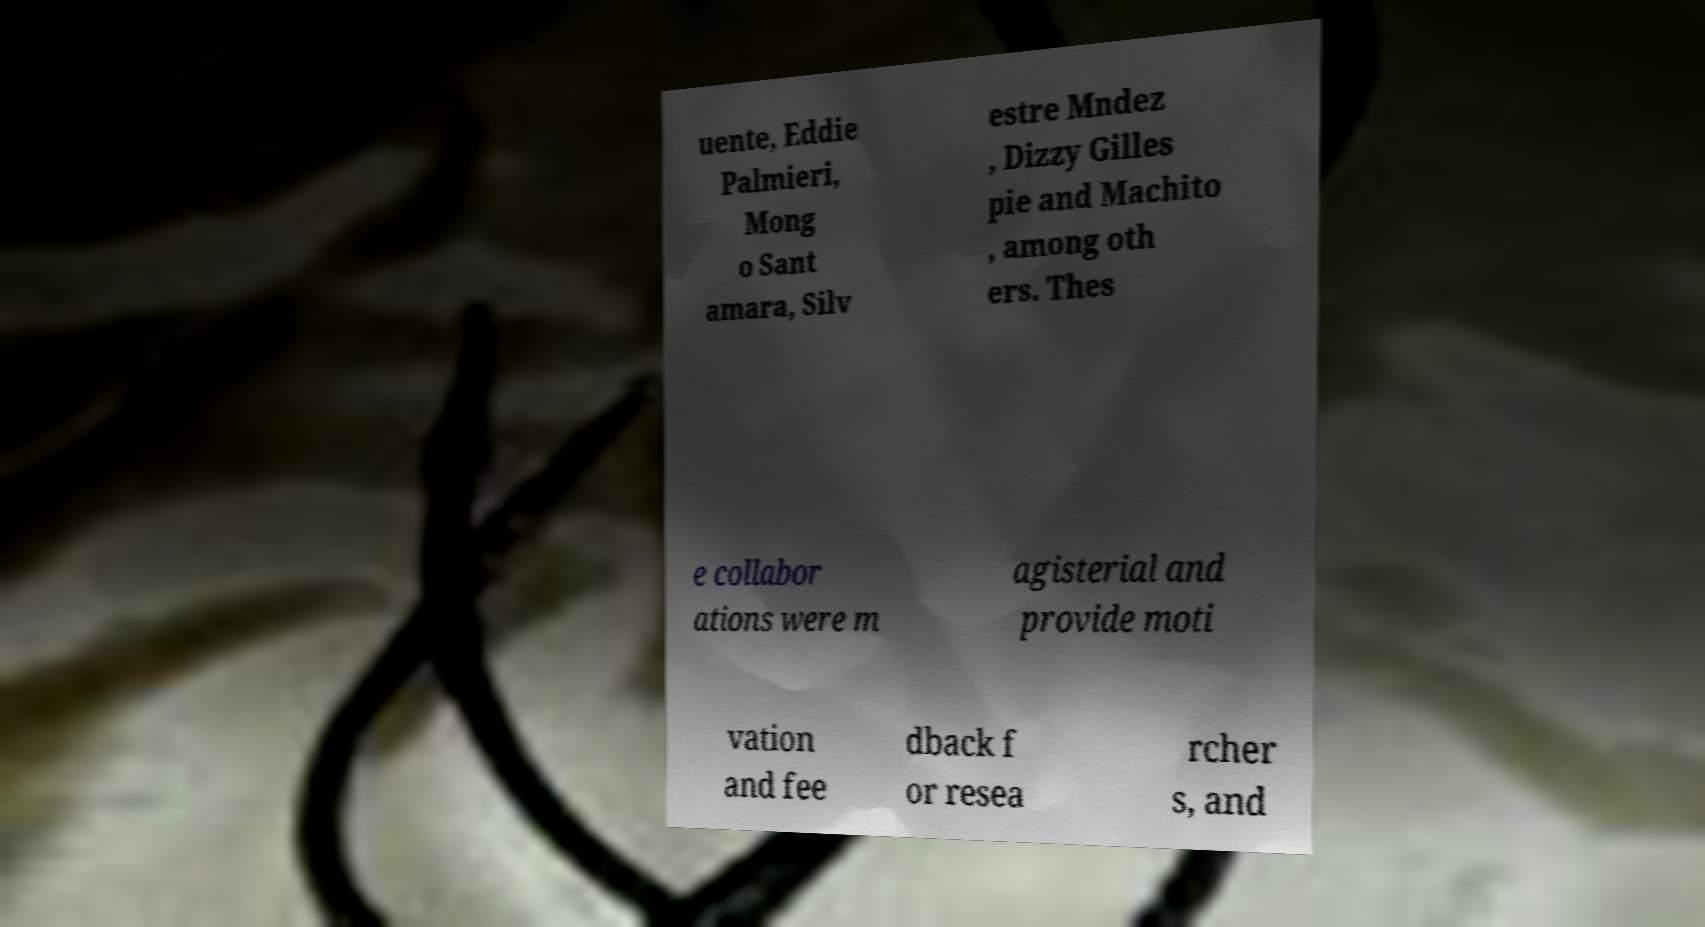Could you assist in decoding the text presented in this image and type it out clearly? uente, Eddie Palmieri, Mong o Sant amara, Silv estre Mndez , Dizzy Gilles pie and Machito , among oth ers. Thes e collabor ations were m agisterial and provide moti vation and fee dback f or resea rcher s, and 